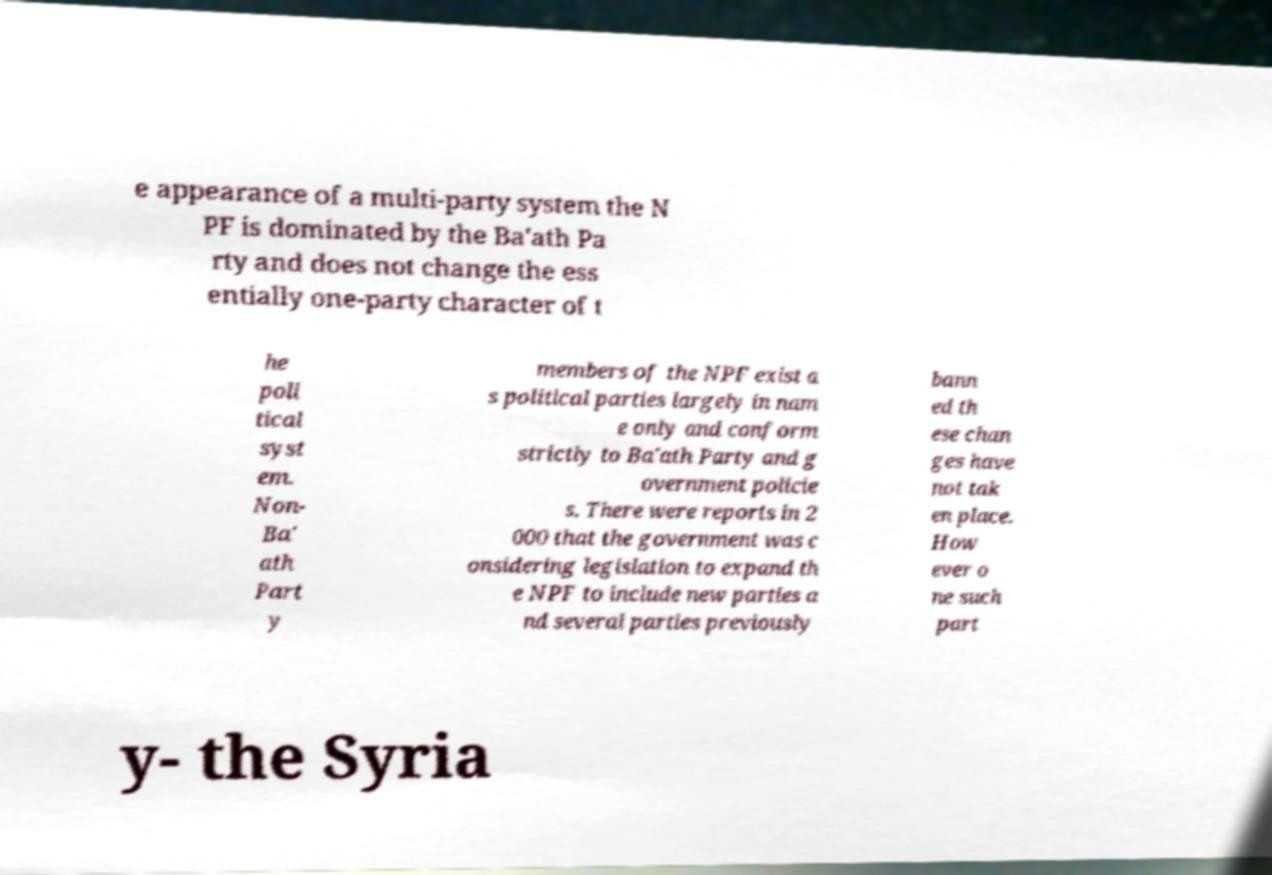Please read and relay the text visible in this image. What does it say? e appearance of a multi-party system the N PF is dominated by the Ba'ath Pa rty and does not change the ess entially one-party character of t he poli tical syst em. Non- Ba' ath Part y members of the NPF exist a s political parties largely in nam e only and conform strictly to Ba'ath Party and g overnment policie s. There were reports in 2 000 that the government was c onsidering legislation to expand th e NPF to include new parties a nd several parties previously bann ed th ese chan ges have not tak en place. How ever o ne such part y- the Syria 